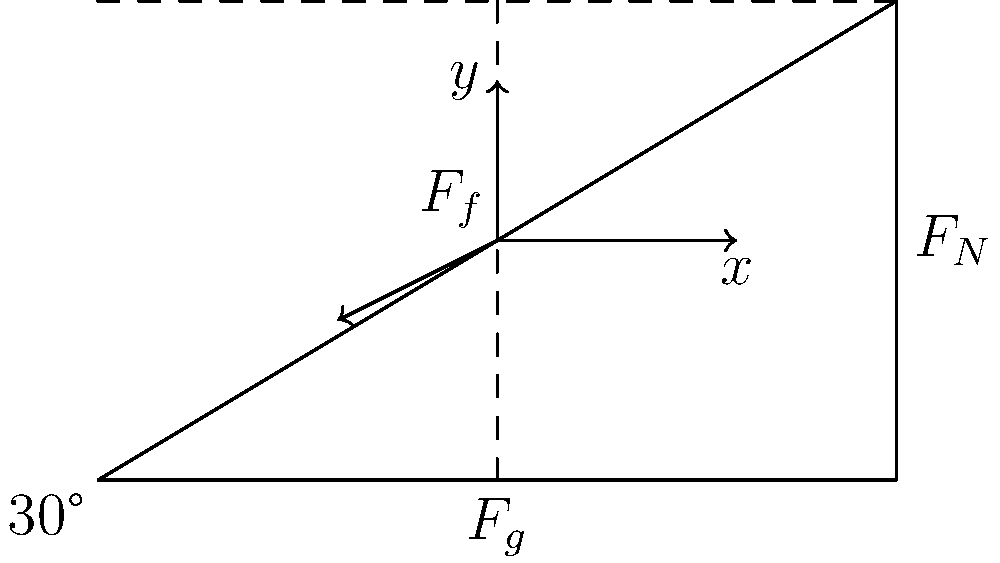As a graphic designer creating visuals for physics wiki pages, you need to illustrate the forces acting on an object on an inclined plane. The plane is inclined at an angle of 30° to the horizontal. Identify and explain the three main forces acting on the object, and determine which force(s) cause the object to accelerate down the plane. 1. Identify the three main forces:
   a) Gravitational force ($F_g$): Acts downward due to Earth's gravity.
   b) Normal force ($F_N$): Perpendicular to the inclined surface, balancing the perpendicular component of gravity.
   c) Friction force ($F_f$): Acts parallel to the surface, opposing motion.

2. Break down the gravitational force into components:
   a) Parallel to the plane: $F_g \sin(30°)$ - causes acceleration down the plane
   b) Perpendicular to the plane: $F_g \cos(30°)$ - balanced by normal force

3. Analyze the forces:
   a) $F_N = F_g \cos(30°)$ (normal force balances perpendicular component of gravity)
   b) Net force down the plane = $F_g \sin(30°) - F_f$

4. Determine the cause of acceleration:
   The component of gravitational force parallel to the plane ($F_g \sin(30°)$) is the primary force causing acceleration down the plane. Friction opposes this motion but is typically smaller in magnitude.

5. Conclusion:
   The object accelerates down the plane due to the net force resulting from the parallel component of gravity minus the friction force.
Answer: Gravitational force component parallel to the plane ($F_g \sin(30°)$) causes acceleration, opposed by friction. 